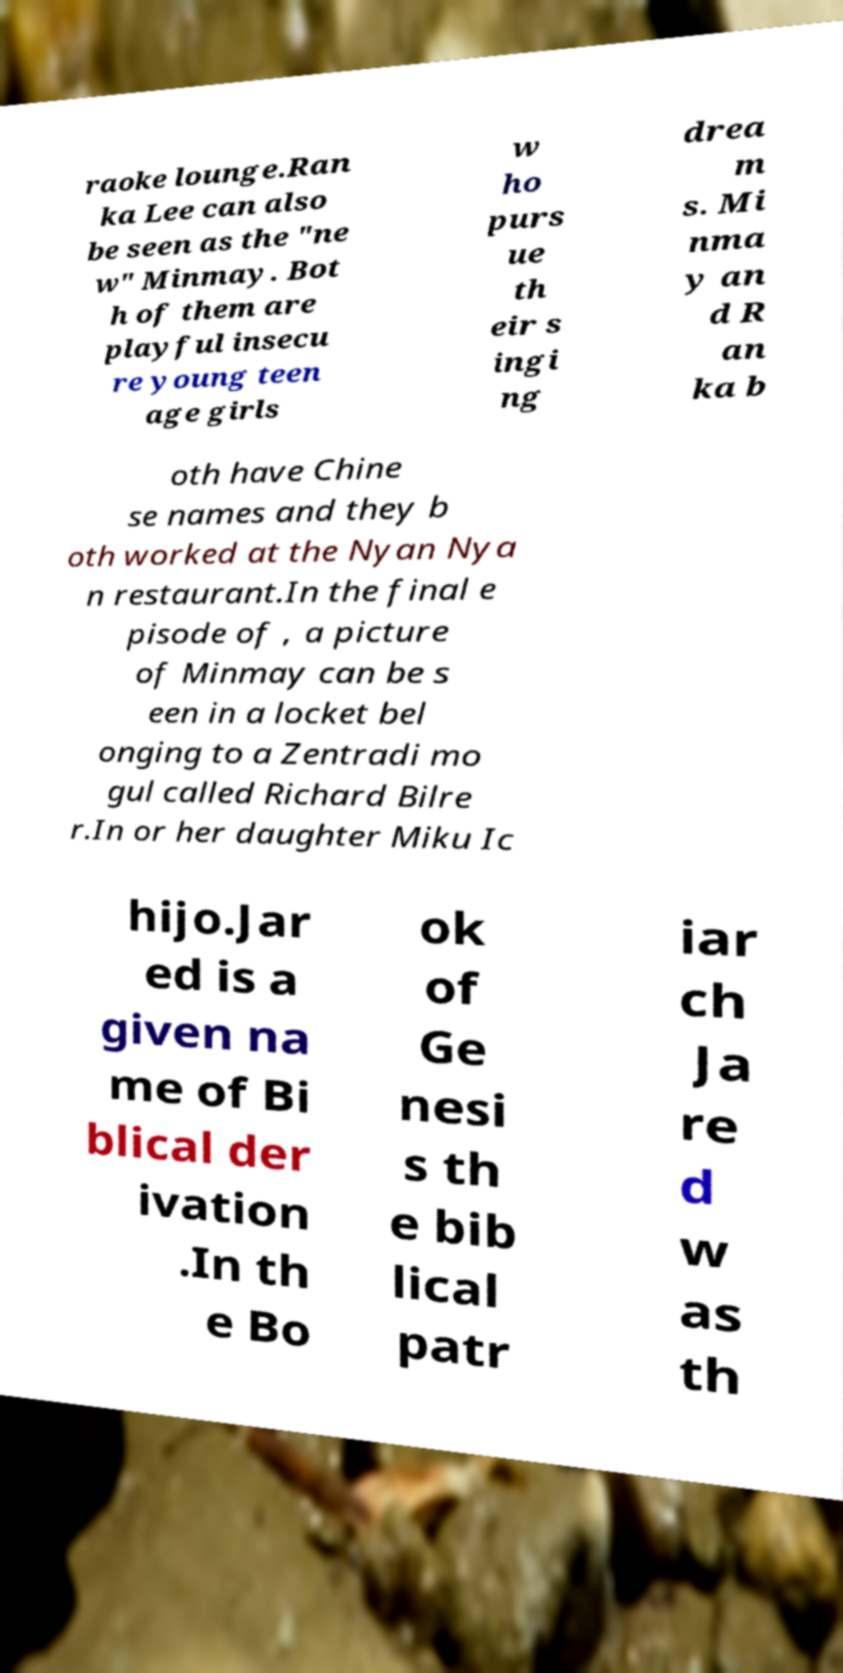Could you assist in decoding the text presented in this image and type it out clearly? raoke lounge.Ran ka Lee can also be seen as the "ne w" Minmay. Bot h of them are playful insecu re young teen age girls w ho purs ue th eir s ingi ng drea m s. Mi nma y an d R an ka b oth have Chine se names and they b oth worked at the Nyan Nya n restaurant.In the final e pisode of , a picture of Minmay can be s een in a locket bel onging to a Zentradi mo gul called Richard Bilre r.In or her daughter Miku Ic hijo.Jar ed is a given na me of Bi blical der ivation .In th e Bo ok of Ge nesi s th e bib lical patr iar ch Ja re d w as th 